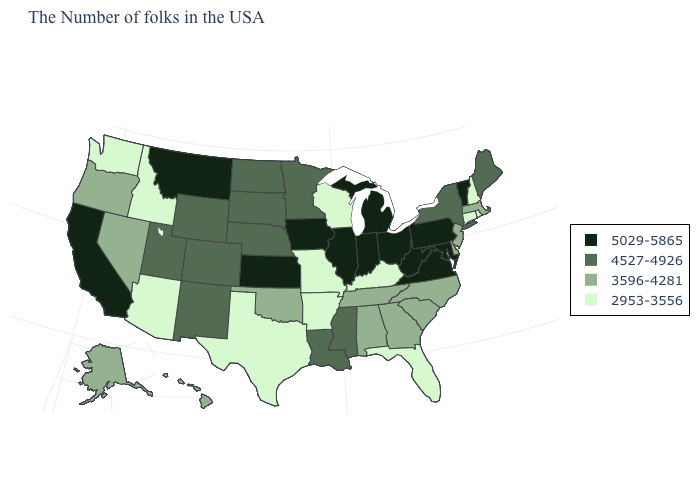What is the value of Texas?
Answer briefly. 2953-3556. Is the legend a continuous bar?
Quick response, please. No. What is the value of West Virginia?
Be succinct. 5029-5865. Name the states that have a value in the range 5029-5865?
Give a very brief answer. Vermont, Maryland, Pennsylvania, Virginia, West Virginia, Ohio, Michigan, Indiana, Illinois, Iowa, Kansas, Montana, California. What is the lowest value in states that border Mississippi?
Give a very brief answer. 2953-3556. What is the value of Pennsylvania?
Answer briefly. 5029-5865. What is the highest value in the MidWest ?
Answer briefly. 5029-5865. Name the states that have a value in the range 5029-5865?
Concise answer only. Vermont, Maryland, Pennsylvania, Virginia, West Virginia, Ohio, Michigan, Indiana, Illinois, Iowa, Kansas, Montana, California. Name the states that have a value in the range 4527-4926?
Write a very short answer. Maine, New York, Mississippi, Louisiana, Minnesota, Nebraska, South Dakota, North Dakota, Wyoming, Colorado, New Mexico, Utah. What is the lowest value in the Northeast?
Give a very brief answer. 2953-3556. What is the lowest value in states that border California?
Write a very short answer. 2953-3556. Among the states that border Arkansas , does Texas have the lowest value?
Concise answer only. Yes. Among the states that border California , does Nevada have the highest value?
Short answer required. Yes. What is the lowest value in the USA?
Give a very brief answer. 2953-3556. Name the states that have a value in the range 2953-3556?
Be succinct. Rhode Island, New Hampshire, Connecticut, Florida, Kentucky, Wisconsin, Missouri, Arkansas, Texas, Arizona, Idaho, Washington. 